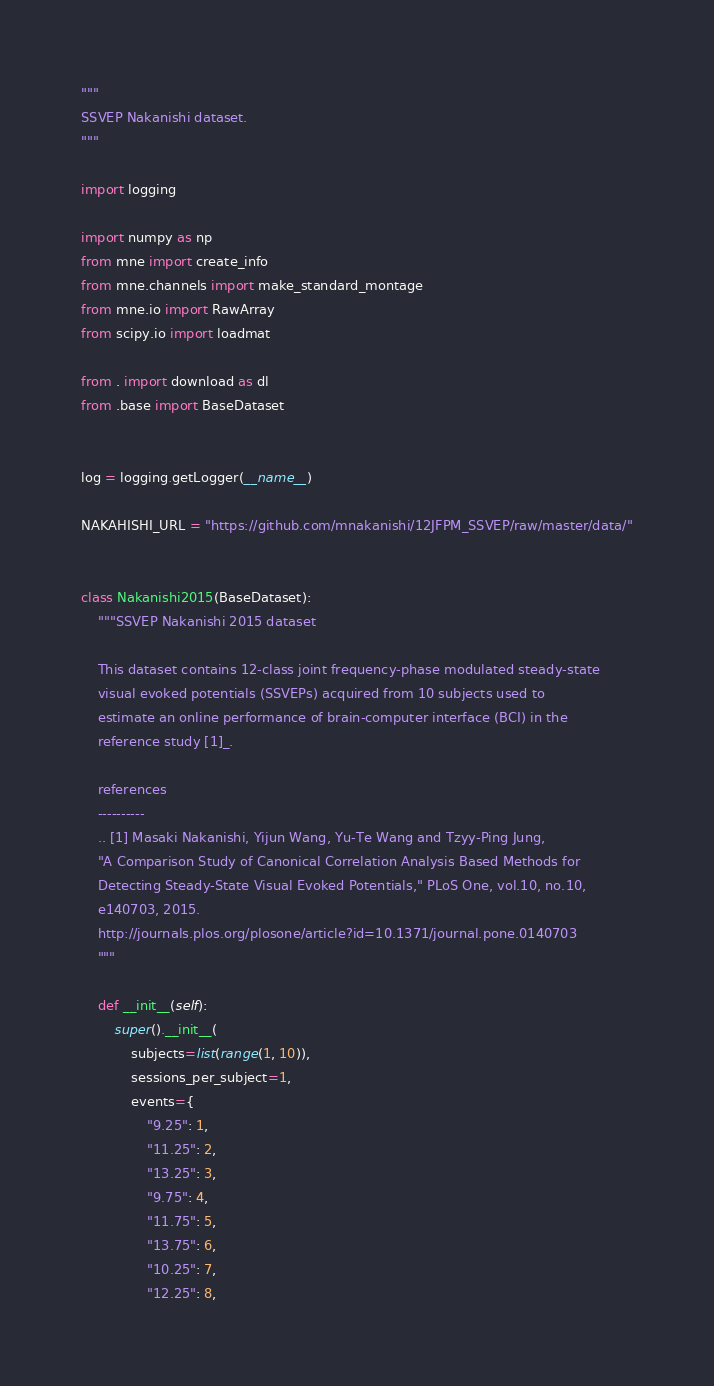Convert code to text. <code><loc_0><loc_0><loc_500><loc_500><_Python_>"""
SSVEP Nakanishi dataset.
"""

import logging

import numpy as np
from mne import create_info
from mne.channels import make_standard_montage
from mne.io import RawArray
from scipy.io import loadmat

from . import download as dl
from .base import BaseDataset


log = logging.getLogger(__name__)

NAKAHISHI_URL = "https://github.com/mnakanishi/12JFPM_SSVEP/raw/master/data/"


class Nakanishi2015(BaseDataset):
    """SSVEP Nakanishi 2015 dataset

    This dataset contains 12-class joint frequency-phase modulated steady-state
    visual evoked potentials (SSVEPs) acquired from 10 subjects used to
    estimate an online performance of brain-computer interface (BCI) in the
    reference study [1]_.

    references
    ----------
    .. [1] Masaki Nakanishi, Yijun Wang, Yu-Te Wang and Tzyy-Ping Jung,
    "A Comparison Study of Canonical Correlation Analysis Based Methods for
    Detecting Steady-State Visual Evoked Potentials," PLoS One, vol.10, no.10,
    e140703, 2015.
    http://journals.plos.org/plosone/article?id=10.1371/journal.pone.0140703
    """

    def __init__(self):
        super().__init__(
            subjects=list(range(1, 10)),
            sessions_per_subject=1,
            events={
                "9.25": 1,
                "11.25": 2,
                "13.25": 3,
                "9.75": 4,
                "11.75": 5,
                "13.75": 6,
                "10.25": 7,
                "12.25": 8,</code> 